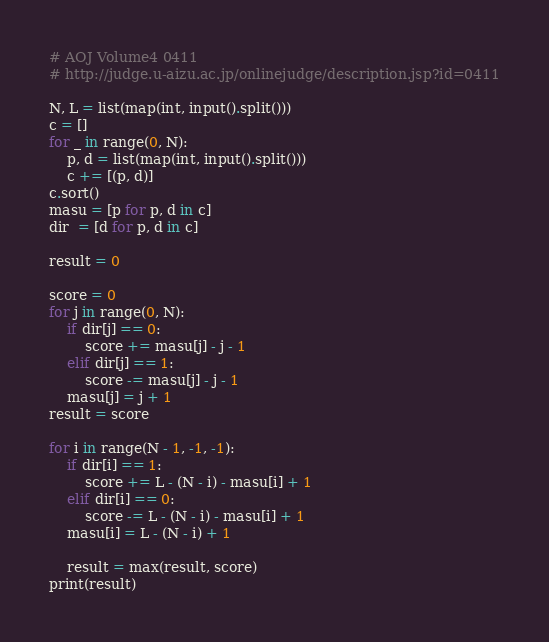Convert code to text. <code><loc_0><loc_0><loc_500><loc_500><_Python_># AOJ Volume4 0411
# http://judge.u-aizu.ac.jp/onlinejudge/description.jsp?id=0411

N, L = list(map(int, input().split()))
c = []
for _ in range(0, N):
    p, d = list(map(int, input().split()))
    c += [(p, d)]
c.sort()
masu = [p for p, d in c]
dir  = [d for p, d in c]

result = 0

score = 0
for j in range(0, N):
    if dir[j] == 0:
        score += masu[j] - j - 1
    elif dir[j] == 1:
        score -= masu[j] - j - 1
    masu[j] = j + 1
result = score

for i in range(N - 1, -1, -1):
    if dir[i] == 1:
        score += L - (N - i) - masu[i] + 1
    elif dir[i] == 0:
        score -= L - (N - i) - masu[i] + 1
    masu[i] = L - (N - i) + 1
    
    result = max(result, score)
print(result)

</code> 